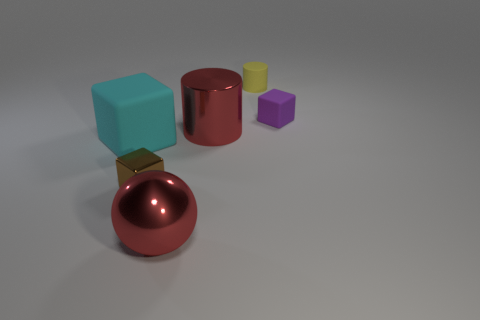Add 4 big brown cylinders. How many objects exist? 10 Subtract all small brown cubes. How many cubes are left? 2 Subtract all yellow cylinders. How many cylinders are left? 1 Subtract all cylinders. How many objects are left? 4 Subtract 3 blocks. How many blocks are left? 0 Subtract all large red metallic cylinders. Subtract all purple objects. How many objects are left? 4 Add 4 purple matte objects. How many purple matte objects are left? 5 Add 2 yellow matte cylinders. How many yellow matte cylinders exist? 3 Subtract 0 red cubes. How many objects are left? 6 Subtract all yellow cylinders. Subtract all blue balls. How many cylinders are left? 1 